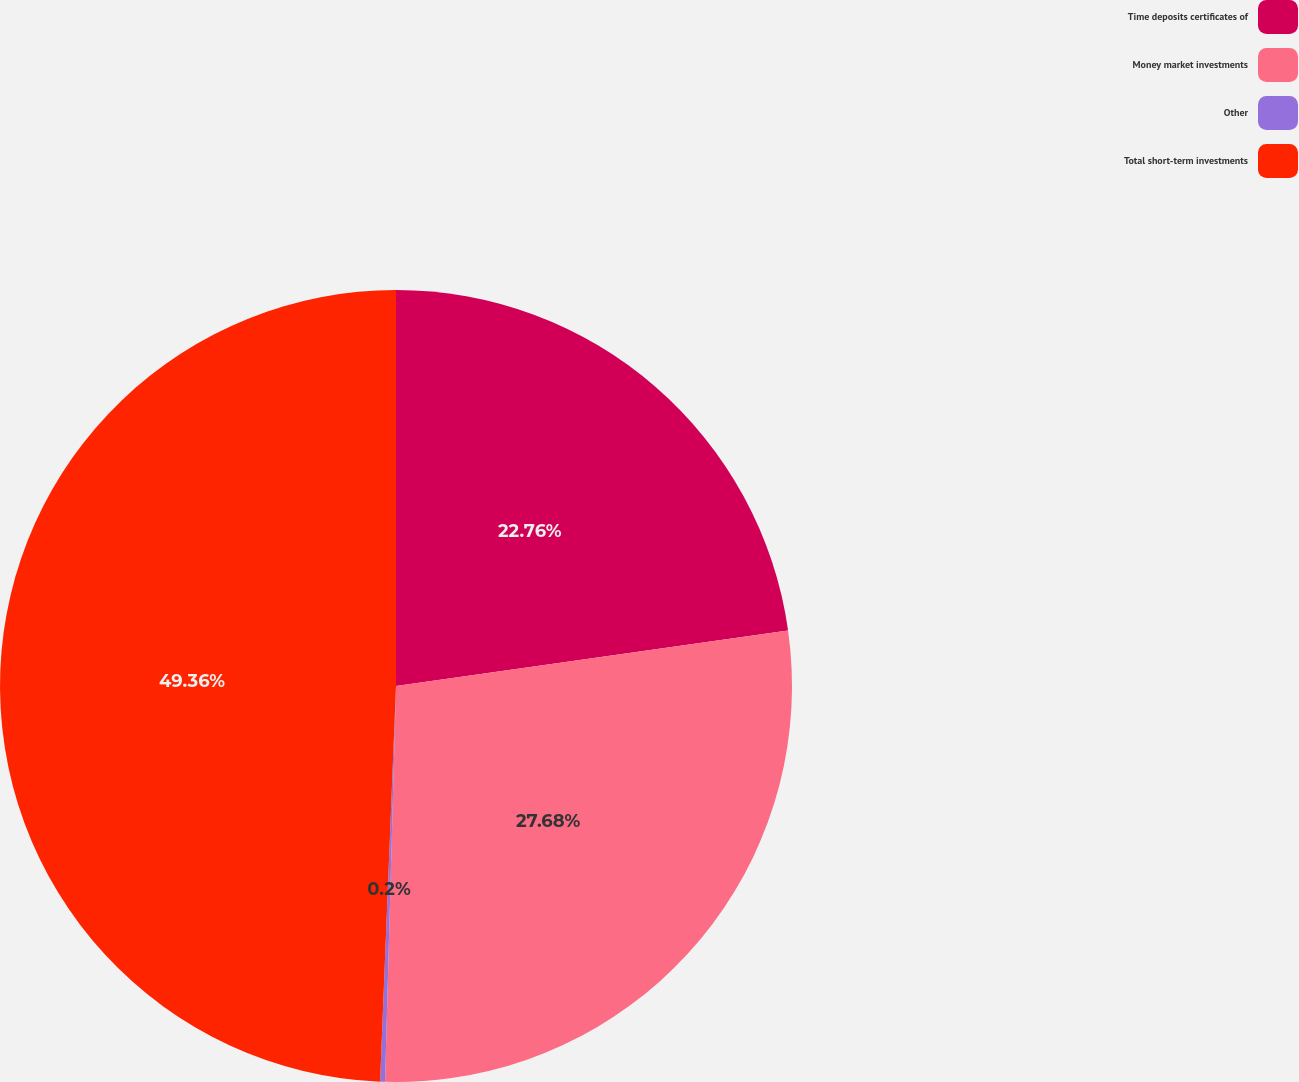<chart> <loc_0><loc_0><loc_500><loc_500><pie_chart><fcel>Time deposits certificates of<fcel>Money market investments<fcel>Other<fcel>Total short-term investments<nl><fcel>22.76%<fcel>27.68%<fcel>0.2%<fcel>49.36%<nl></chart> 